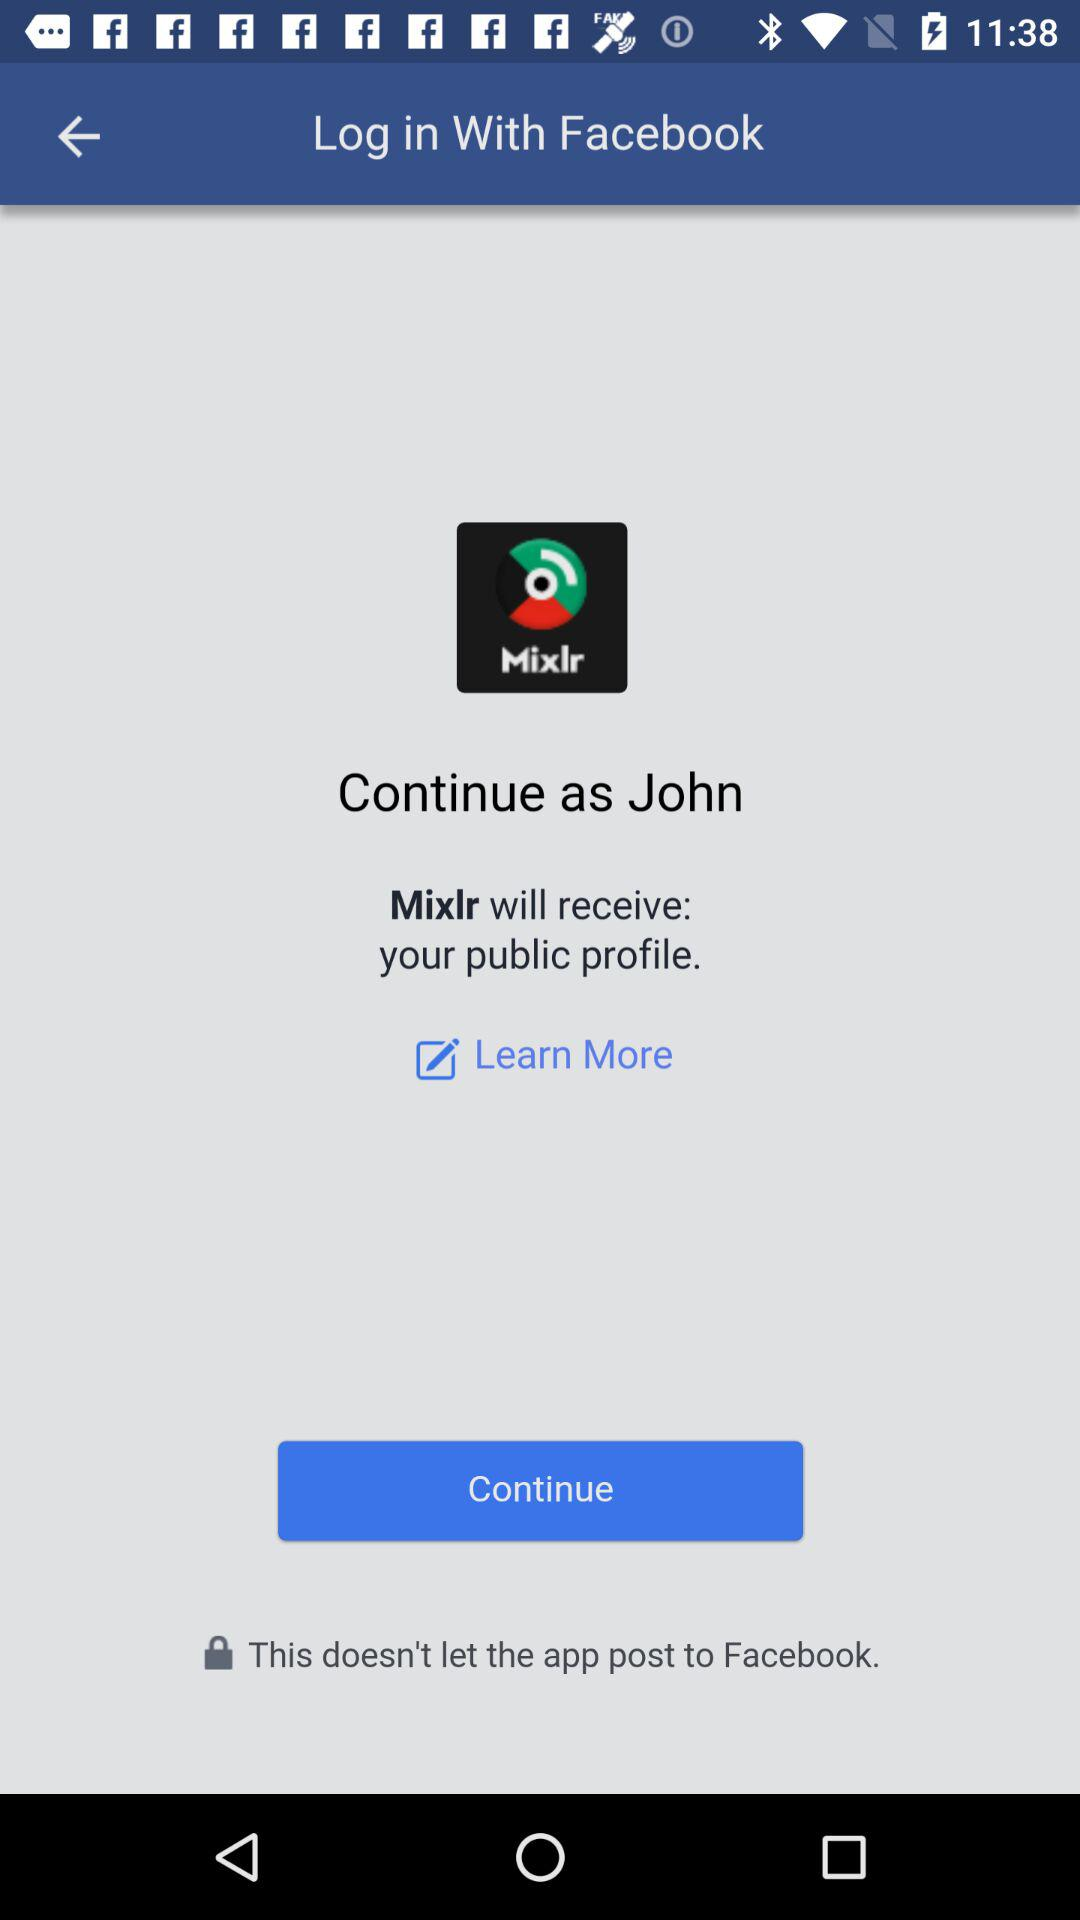What's the name of the user by whom the application can be continued? The name of the user is John. 